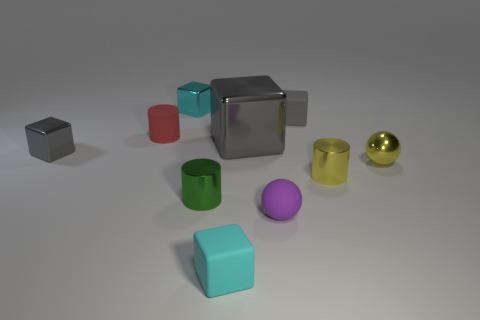Does the tiny gray object on the left side of the purple thing have the same material as the tiny gray thing behind the large cube?
Provide a short and direct response. No. Is the tiny green thing made of the same material as the purple ball?
Your response must be concise. No. Are there fewer red matte things than gray metallic blocks?
Provide a short and direct response. Yes. Does the green thing have the same shape as the small red object?
Give a very brief answer. Yes. The big metallic thing has what color?
Offer a terse response. Gray. What number of other objects are there of the same material as the small yellow ball?
Give a very brief answer. 5. What number of yellow things are small metallic spheres or rubber objects?
Offer a very short reply. 1. There is a metal object behind the tiny gray rubber block; is it the same shape as the large gray metallic thing that is in front of the small gray rubber object?
Keep it short and to the point. Yes. Is the color of the big object the same as the matte block that is behind the yellow sphere?
Your answer should be compact. Yes. There is a cylinder to the right of the green metallic object; is its color the same as the small metallic ball?
Ensure brevity in your answer.  Yes. 